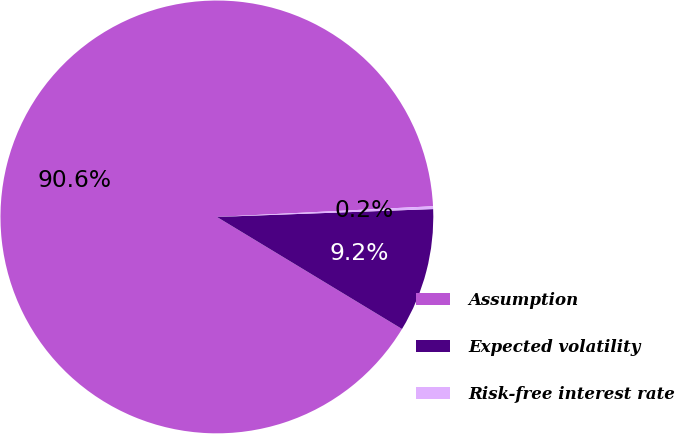Convert chart. <chart><loc_0><loc_0><loc_500><loc_500><pie_chart><fcel>Assumption<fcel>Expected volatility<fcel>Risk-free interest rate<nl><fcel>90.55%<fcel>9.24%<fcel>0.21%<nl></chart> 